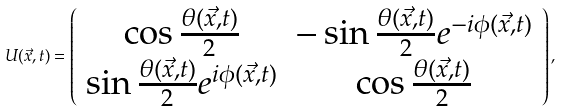Convert formula to latex. <formula><loc_0><loc_0><loc_500><loc_500>U ( \vec { x } , t ) = \left ( \begin{array} { c c } \cos \frac { \theta ( \vec { x } , t ) } { 2 } & - \sin \frac { \theta ( \vec { x } , t ) } { 2 } e ^ { - i \phi ( \vec { x } , t ) } \\ \sin \frac { \theta ( \vec { x } , t ) } { 2 } e ^ { i \phi ( \vec { x } , t ) } & \cos \frac { \theta ( \vec { x } , t ) } { 2 } \end{array} \right ) ,</formula> 